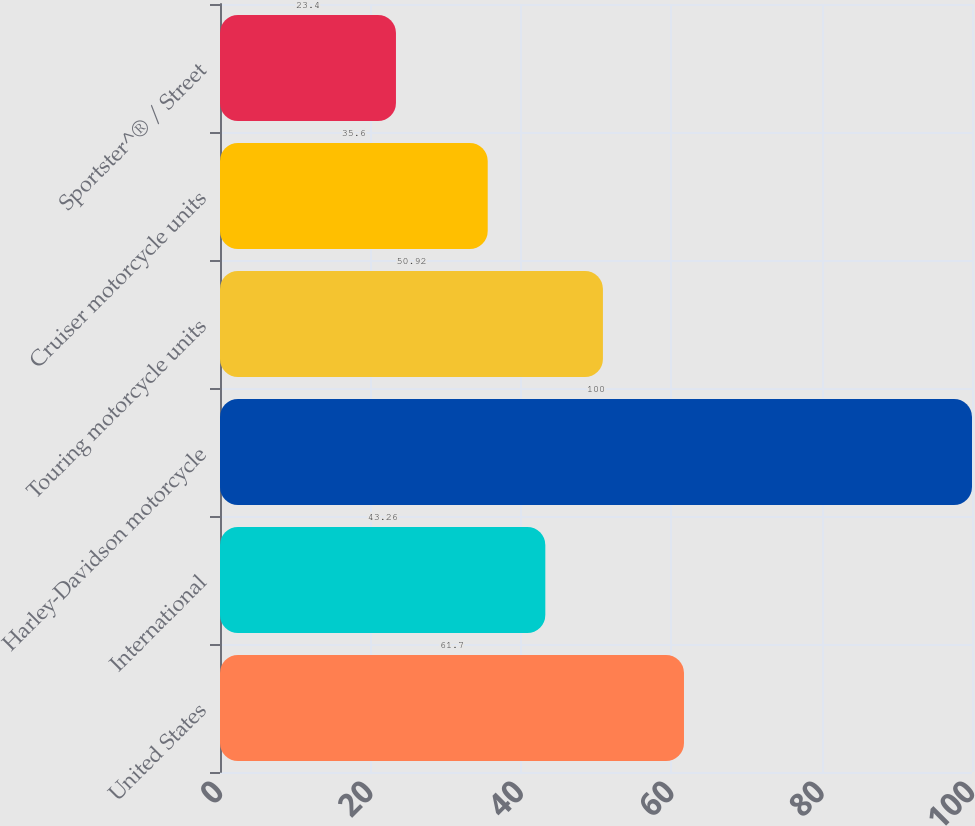Convert chart. <chart><loc_0><loc_0><loc_500><loc_500><bar_chart><fcel>United States<fcel>International<fcel>Harley-Davidson motorcycle<fcel>Touring motorcycle units<fcel>Cruiser motorcycle units<fcel>Sportster^® / Street<nl><fcel>61.7<fcel>43.26<fcel>100<fcel>50.92<fcel>35.6<fcel>23.4<nl></chart> 